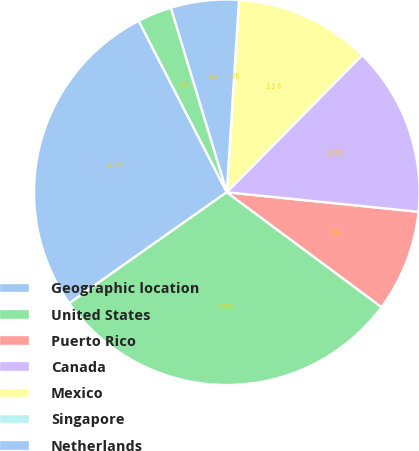Convert chart. <chart><loc_0><loc_0><loc_500><loc_500><pie_chart><fcel>Geographic location<fcel>United States<fcel>Puerto Rico<fcel>Canada<fcel>Mexico<fcel>Singapore<fcel>Netherlands<fcel>China<nl><fcel>27.22%<fcel>30.07%<fcel>8.54%<fcel>14.22%<fcel>11.38%<fcel>0.01%<fcel>5.7%<fcel>2.86%<nl></chart> 